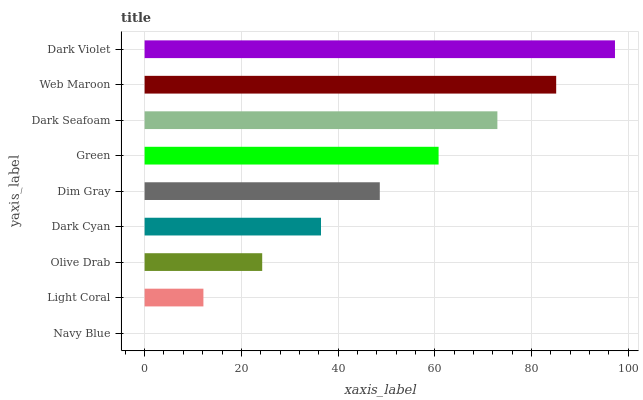Is Navy Blue the minimum?
Answer yes or no. Yes. Is Dark Violet the maximum?
Answer yes or no. Yes. Is Light Coral the minimum?
Answer yes or no. No. Is Light Coral the maximum?
Answer yes or no. No. Is Light Coral greater than Navy Blue?
Answer yes or no. Yes. Is Navy Blue less than Light Coral?
Answer yes or no. Yes. Is Navy Blue greater than Light Coral?
Answer yes or no. No. Is Light Coral less than Navy Blue?
Answer yes or no. No. Is Dim Gray the high median?
Answer yes or no. Yes. Is Dim Gray the low median?
Answer yes or no. Yes. Is Web Maroon the high median?
Answer yes or no. No. Is Dark Seafoam the low median?
Answer yes or no. No. 